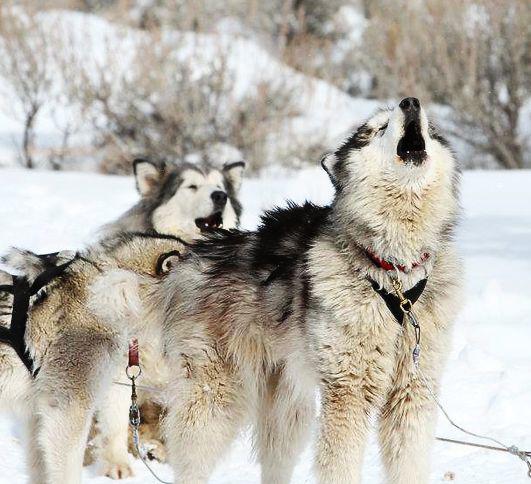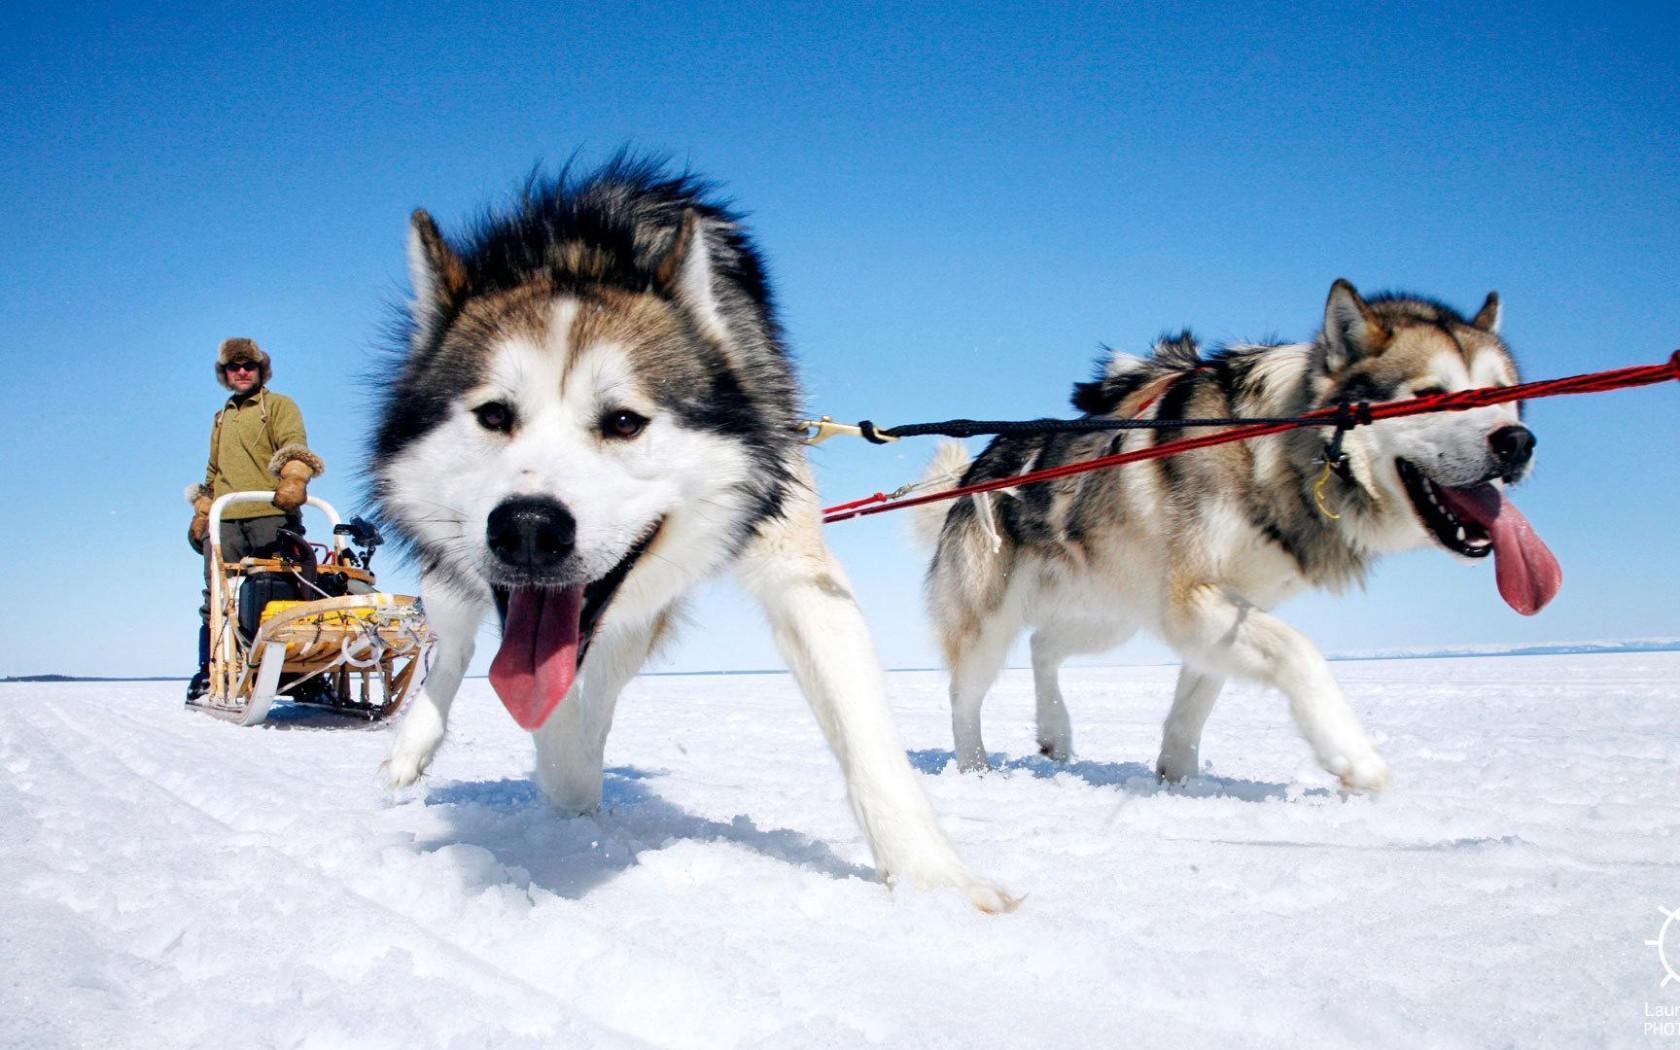The first image is the image on the left, the second image is the image on the right. Analyze the images presented: Is the assertion "One image shows dogs hitched to a sled with a driver standing behind it and moving in a forward direction." valid? Answer yes or no. Yes. 